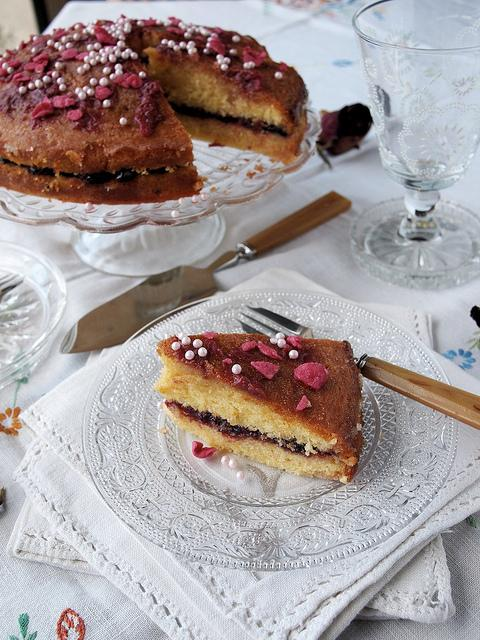What is the filling made of? raspberry 